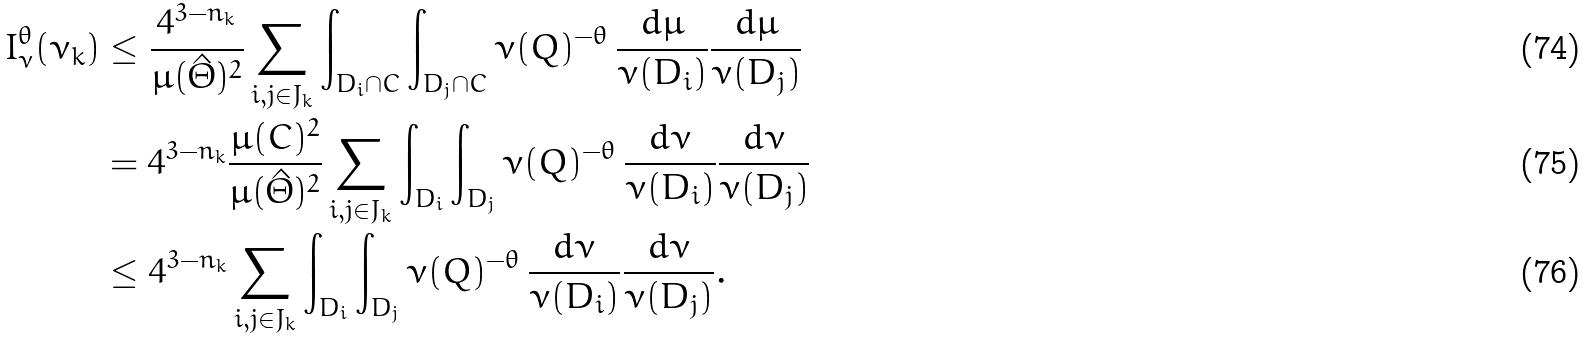<formula> <loc_0><loc_0><loc_500><loc_500>I _ { \nu } ^ { \theta } ( \nu _ { k } ) & \leq \frac { 4 ^ { 3 - n _ { k } } } { \mu ( \hat { \Theta } ) ^ { 2 } } \sum _ { i , j \in J _ { k } } \int _ { D _ { i } \cap C } \int _ { D _ { j } \cap C } \nu ( Q ) ^ { - \theta } \, \frac { d \mu } { \nu ( D _ { i } ) } \frac { d \mu } { \nu ( D _ { j } ) } \\ & = 4 ^ { 3 - n _ { k } } \frac { \mu ( C ) ^ { 2 } } { \mu ( \hat { \Theta } ) ^ { 2 } } \sum _ { i , j \in J _ { k } } \int _ { D _ { i } } \int _ { D _ { j } } \nu ( Q ) ^ { - \theta } \, \frac { d \nu } { \nu ( D _ { i } ) } \frac { d \nu } { \nu ( D _ { j } ) } \\ & \leq 4 ^ { 3 - n _ { k } } \sum _ { i , j \in J _ { k } } \int _ { D _ { i } } \int _ { D _ { j } } \nu ( Q ) ^ { - \theta } \, \frac { d \nu } { \nu ( D _ { i } ) } \frac { d \nu } { \nu ( D _ { j } ) } .</formula> 